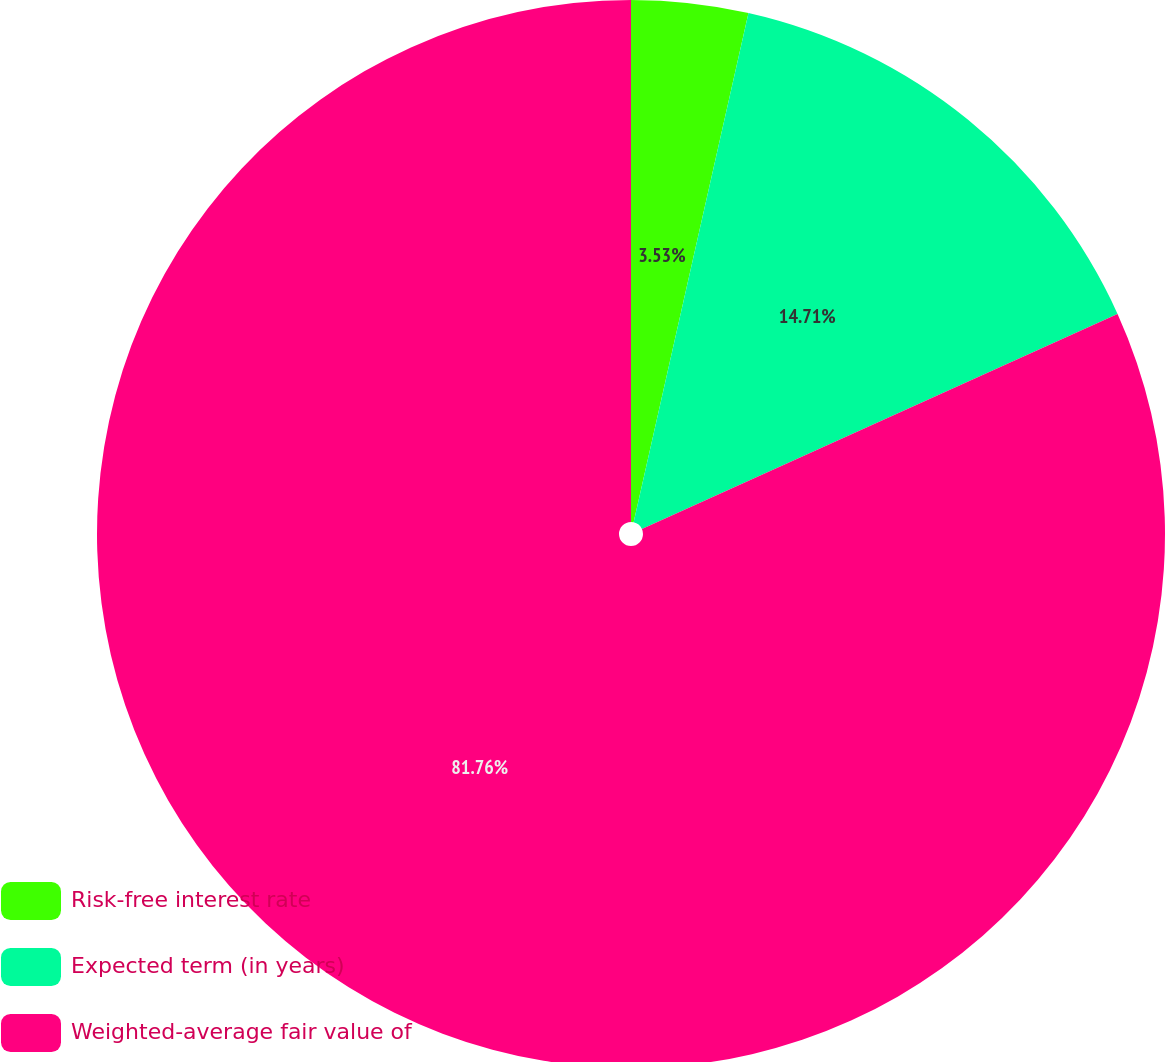Convert chart to OTSL. <chart><loc_0><loc_0><loc_500><loc_500><pie_chart><fcel>Risk-free interest rate<fcel>Expected term (in years)<fcel>Weighted-average fair value of<nl><fcel>3.53%<fcel>14.71%<fcel>81.76%<nl></chart> 